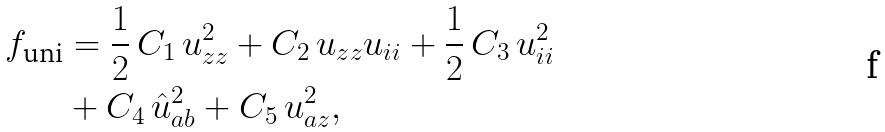Convert formula to latex. <formula><loc_0><loc_0><loc_500><loc_500>f _ { \text {uni} } & = \frac { 1 } { 2 } \, C _ { 1 } \, u _ { z z } ^ { 2 } + C _ { 2 } \, u _ { z z } u _ { i i } + \frac { 1 } { 2 } \, C _ { 3 } \, u _ { i i } ^ { 2 } \\ & + C _ { 4 } \, \hat { u } _ { a b } ^ { 2 } + C _ { 5 } \, u _ { a z } ^ { 2 } ,</formula> 